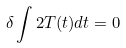Convert formula to latex. <formula><loc_0><loc_0><loc_500><loc_500>\delta \int 2 T ( t ) d t = 0</formula> 